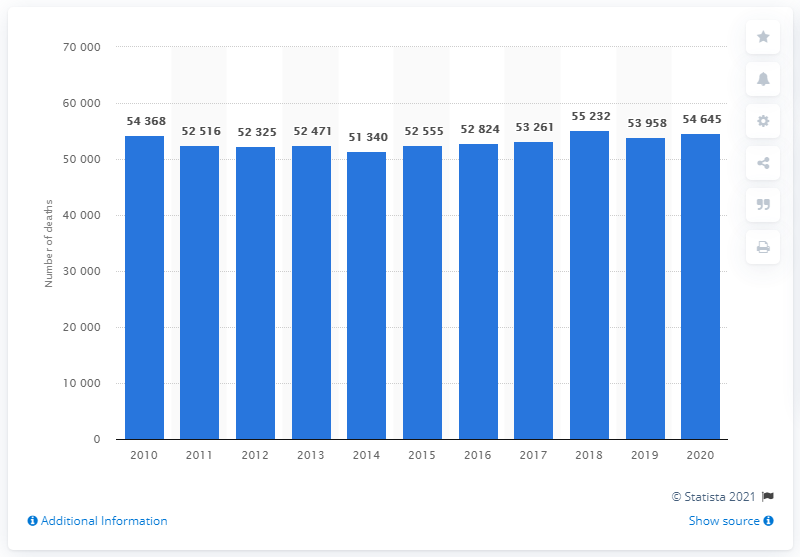Mention a couple of crucial points in this snapshot. In 2018, a total of 54,645 people died in Denmark. In 2014, the number of deaths for males surpassed that of females. 